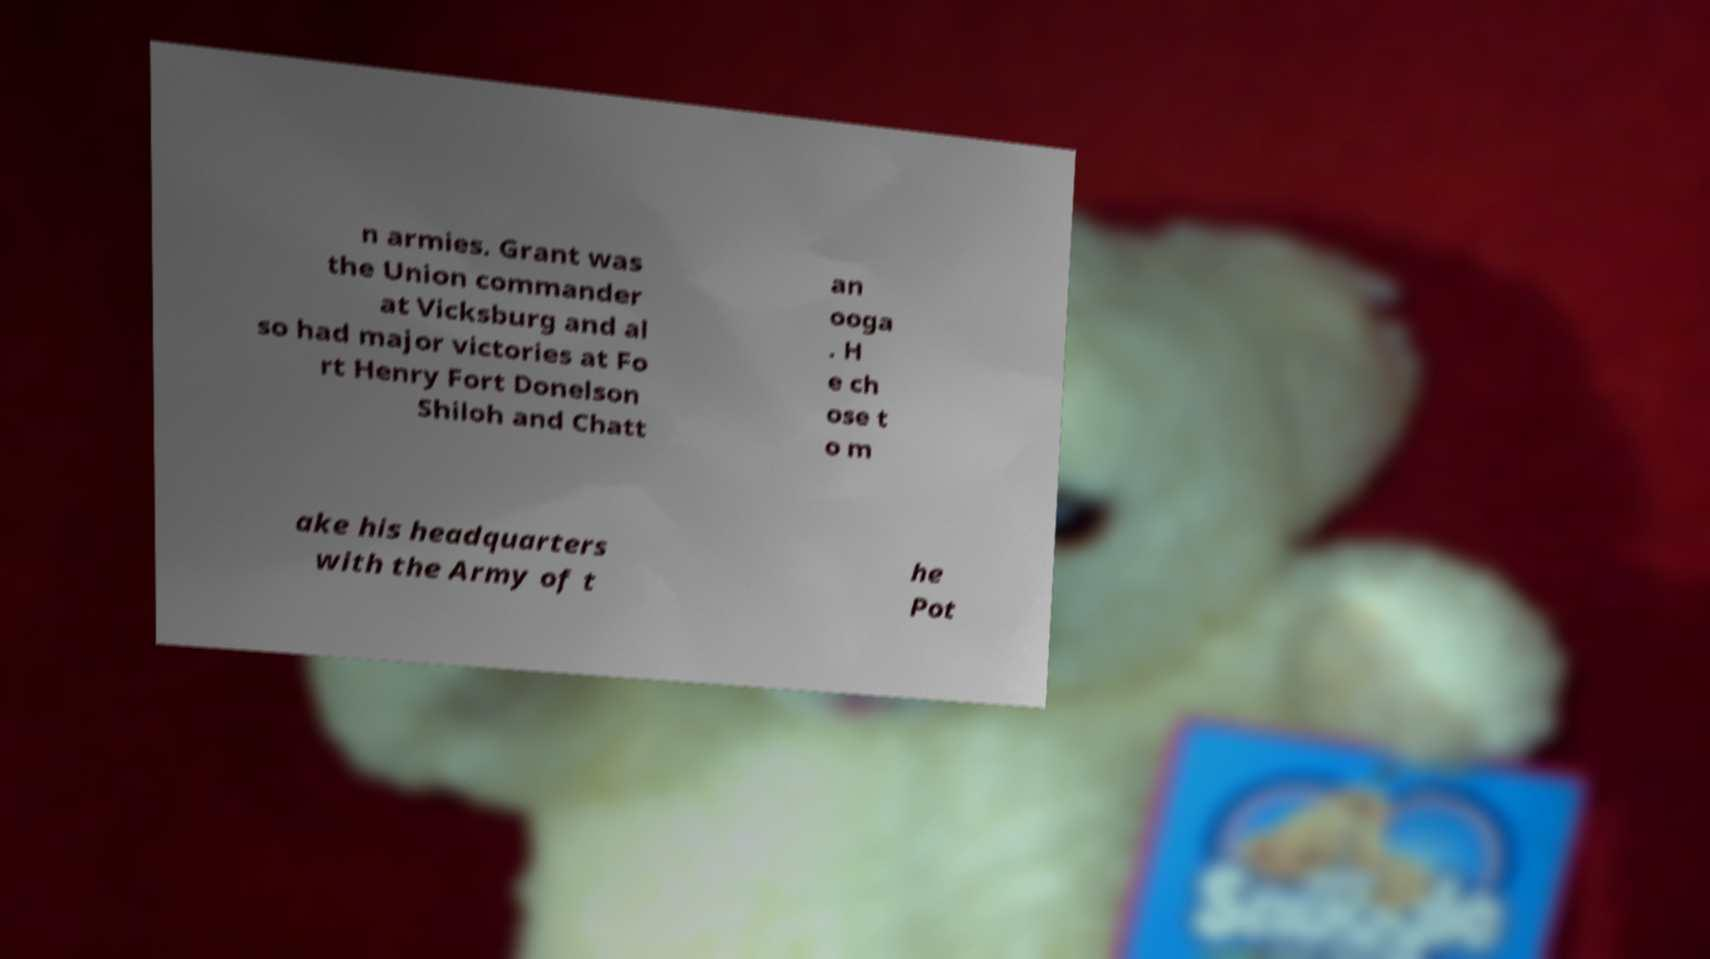Please identify and transcribe the text found in this image. n armies. Grant was the Union commander at Vicksburg and al so had major victories at Fo rt Henry Fort Donelson Shiloh and Chatt an ooga . H e ch ose t o m ake his headquarters with the Army of t he Pot 